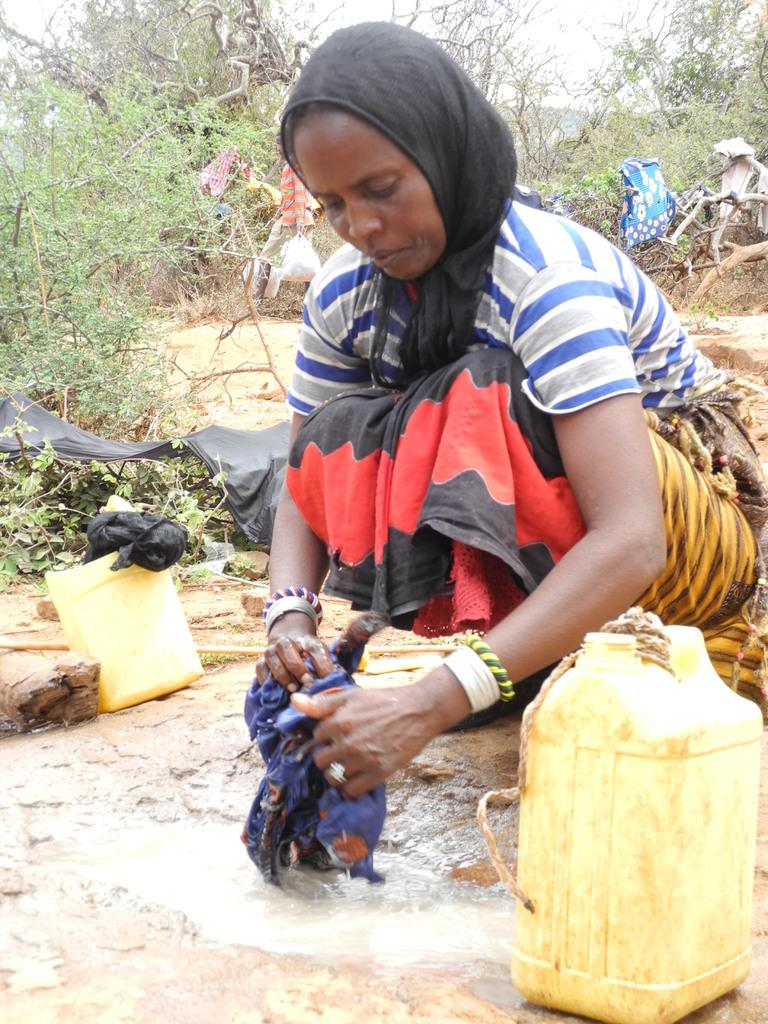Who is the main subject in the image? There is a woman in the image. What position is the woman in? The woman is in a squatting position. What is the woman holding in the image? The woman is holding a cloth. What other objects can be seen in the image? There are water cans, plants, and trees in the image. What color is the spade used by the woman in the image? There is no spade present in the image; the woman is holding a cloth. 